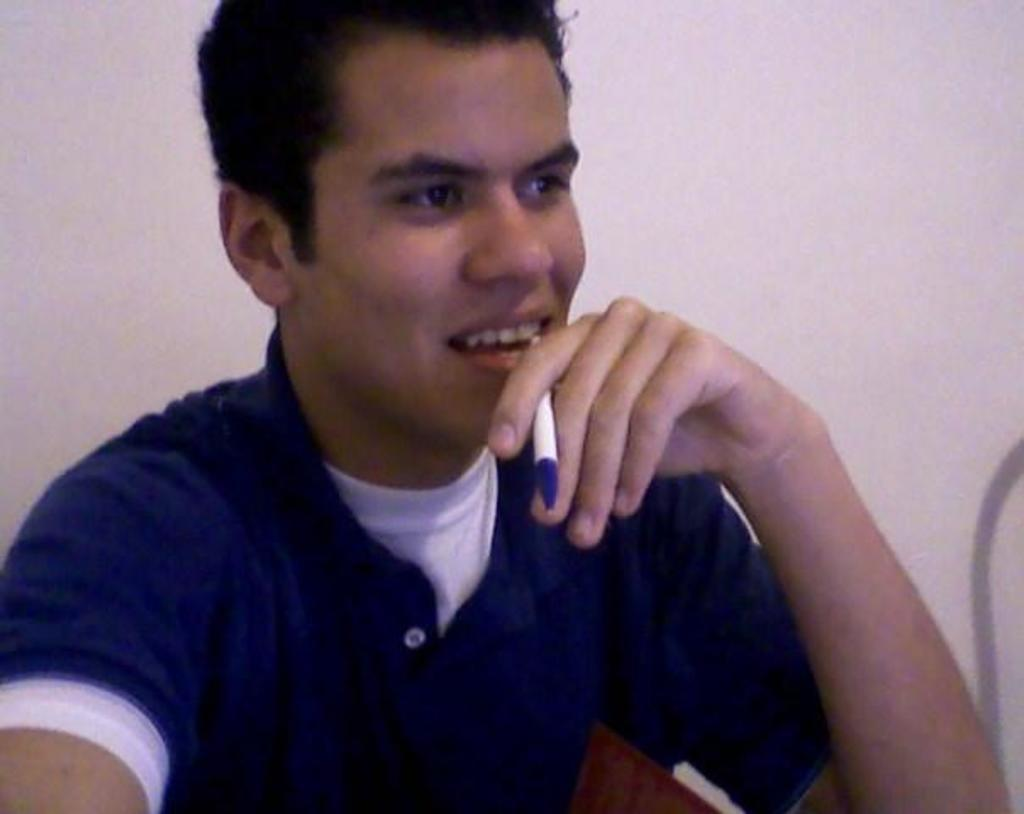What is the main subject of the picture? The main subject of the picture is a man. What is the man holding in the picture? The man is holding a pen. Can you describe the man's clothing in the picture? The man is wearing a blue t-shirt. What type of tree is growing in the man's t-shirt in the image? There is no tree growing in the man's t-shirt in the image. 